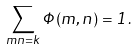<formula> <loc_0><loc_0><loc_500><loc_500>\sum _ { m n = k } \Phi ( m , n ) = 1 .</formula> 